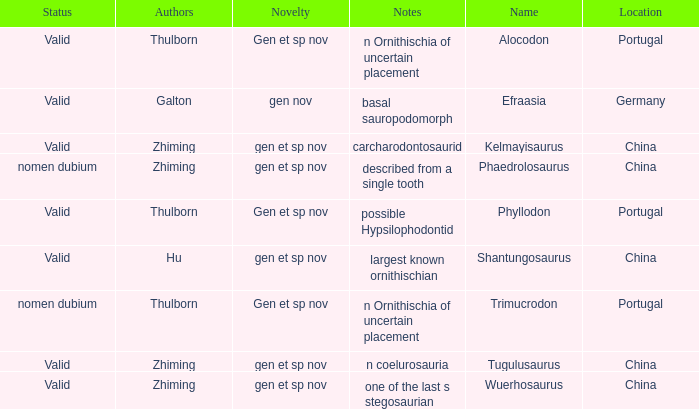What is the Novelty of the dinosaur that was named by the Author, Zhiming, and whose Notes are, "carcharodontosaurid"? Gen et sp nov. 